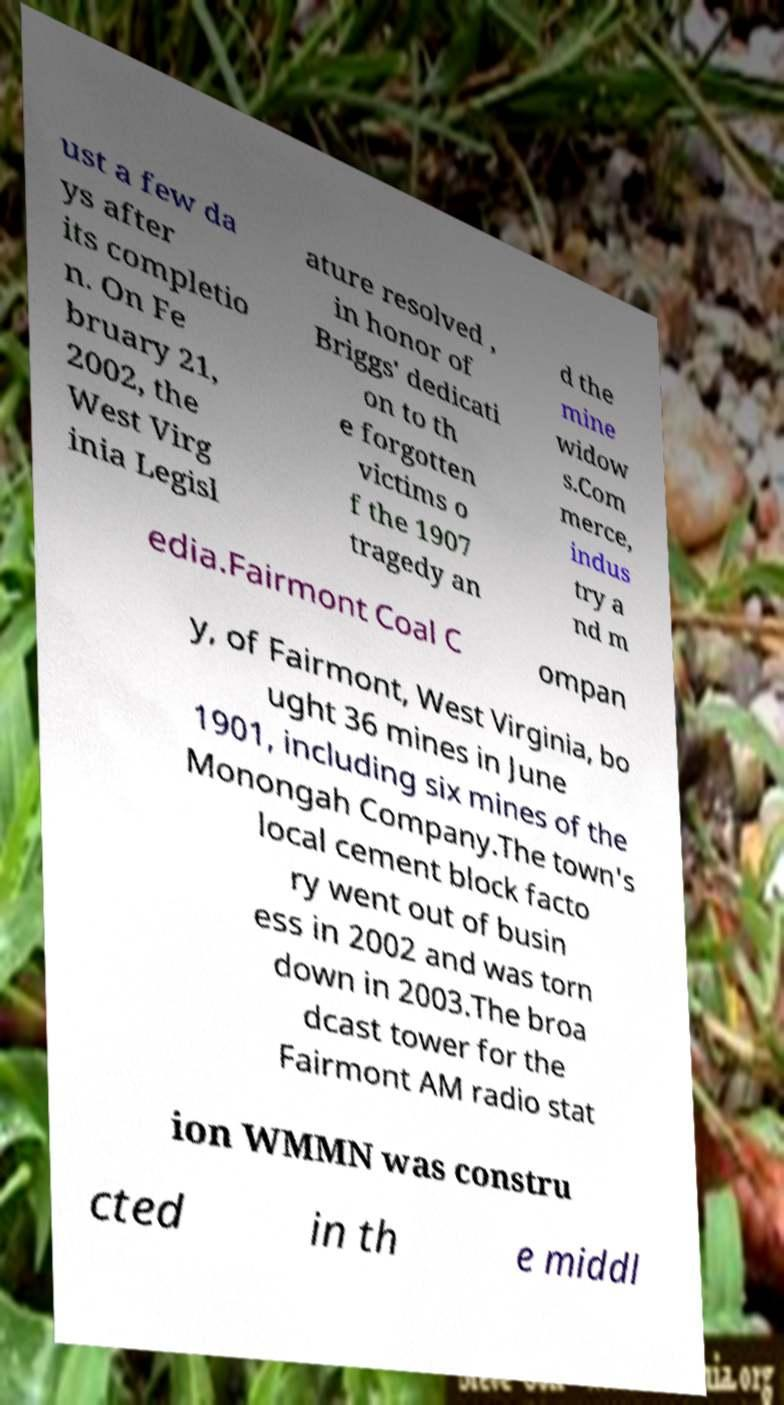I need the written content from this picture converted into text. Can you do that? ust a few da ys after its completio n. On Fe bruary 21, 2002, the West Virg inia Legisl ature resolved , in honor of Briggs' dedicati on to th e forgotten victims o f the 1907 tragedy an d the mine widow s.Com merce, indus try a nd m edia.Fairmont Coal C ompan y, of Fairmont, West Virginia, bo ught 36 mines in June 1901, including six mines of the Monongah Company.The town's local cement block facto ry went out of busin ess in 2002 and was torn down in 2003.The broa dcast tower for the Fairmont AM radio stat ion WMMN was constru cted in th e middl 